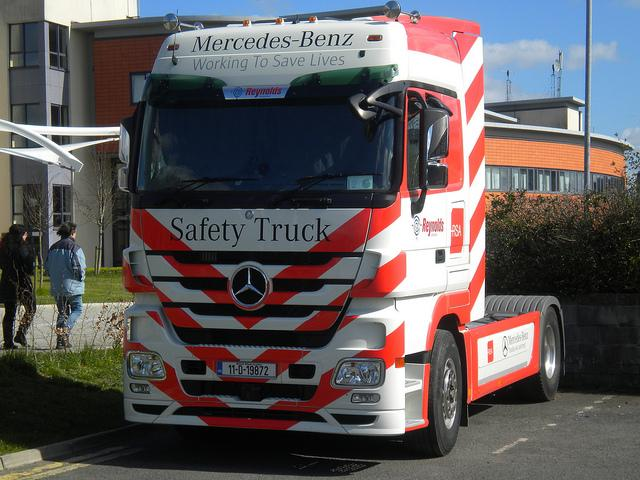What is the most appropriate surface for this truck to drive on? Please explain your reasoning. asphalt. The best place would be on a black top driveway 